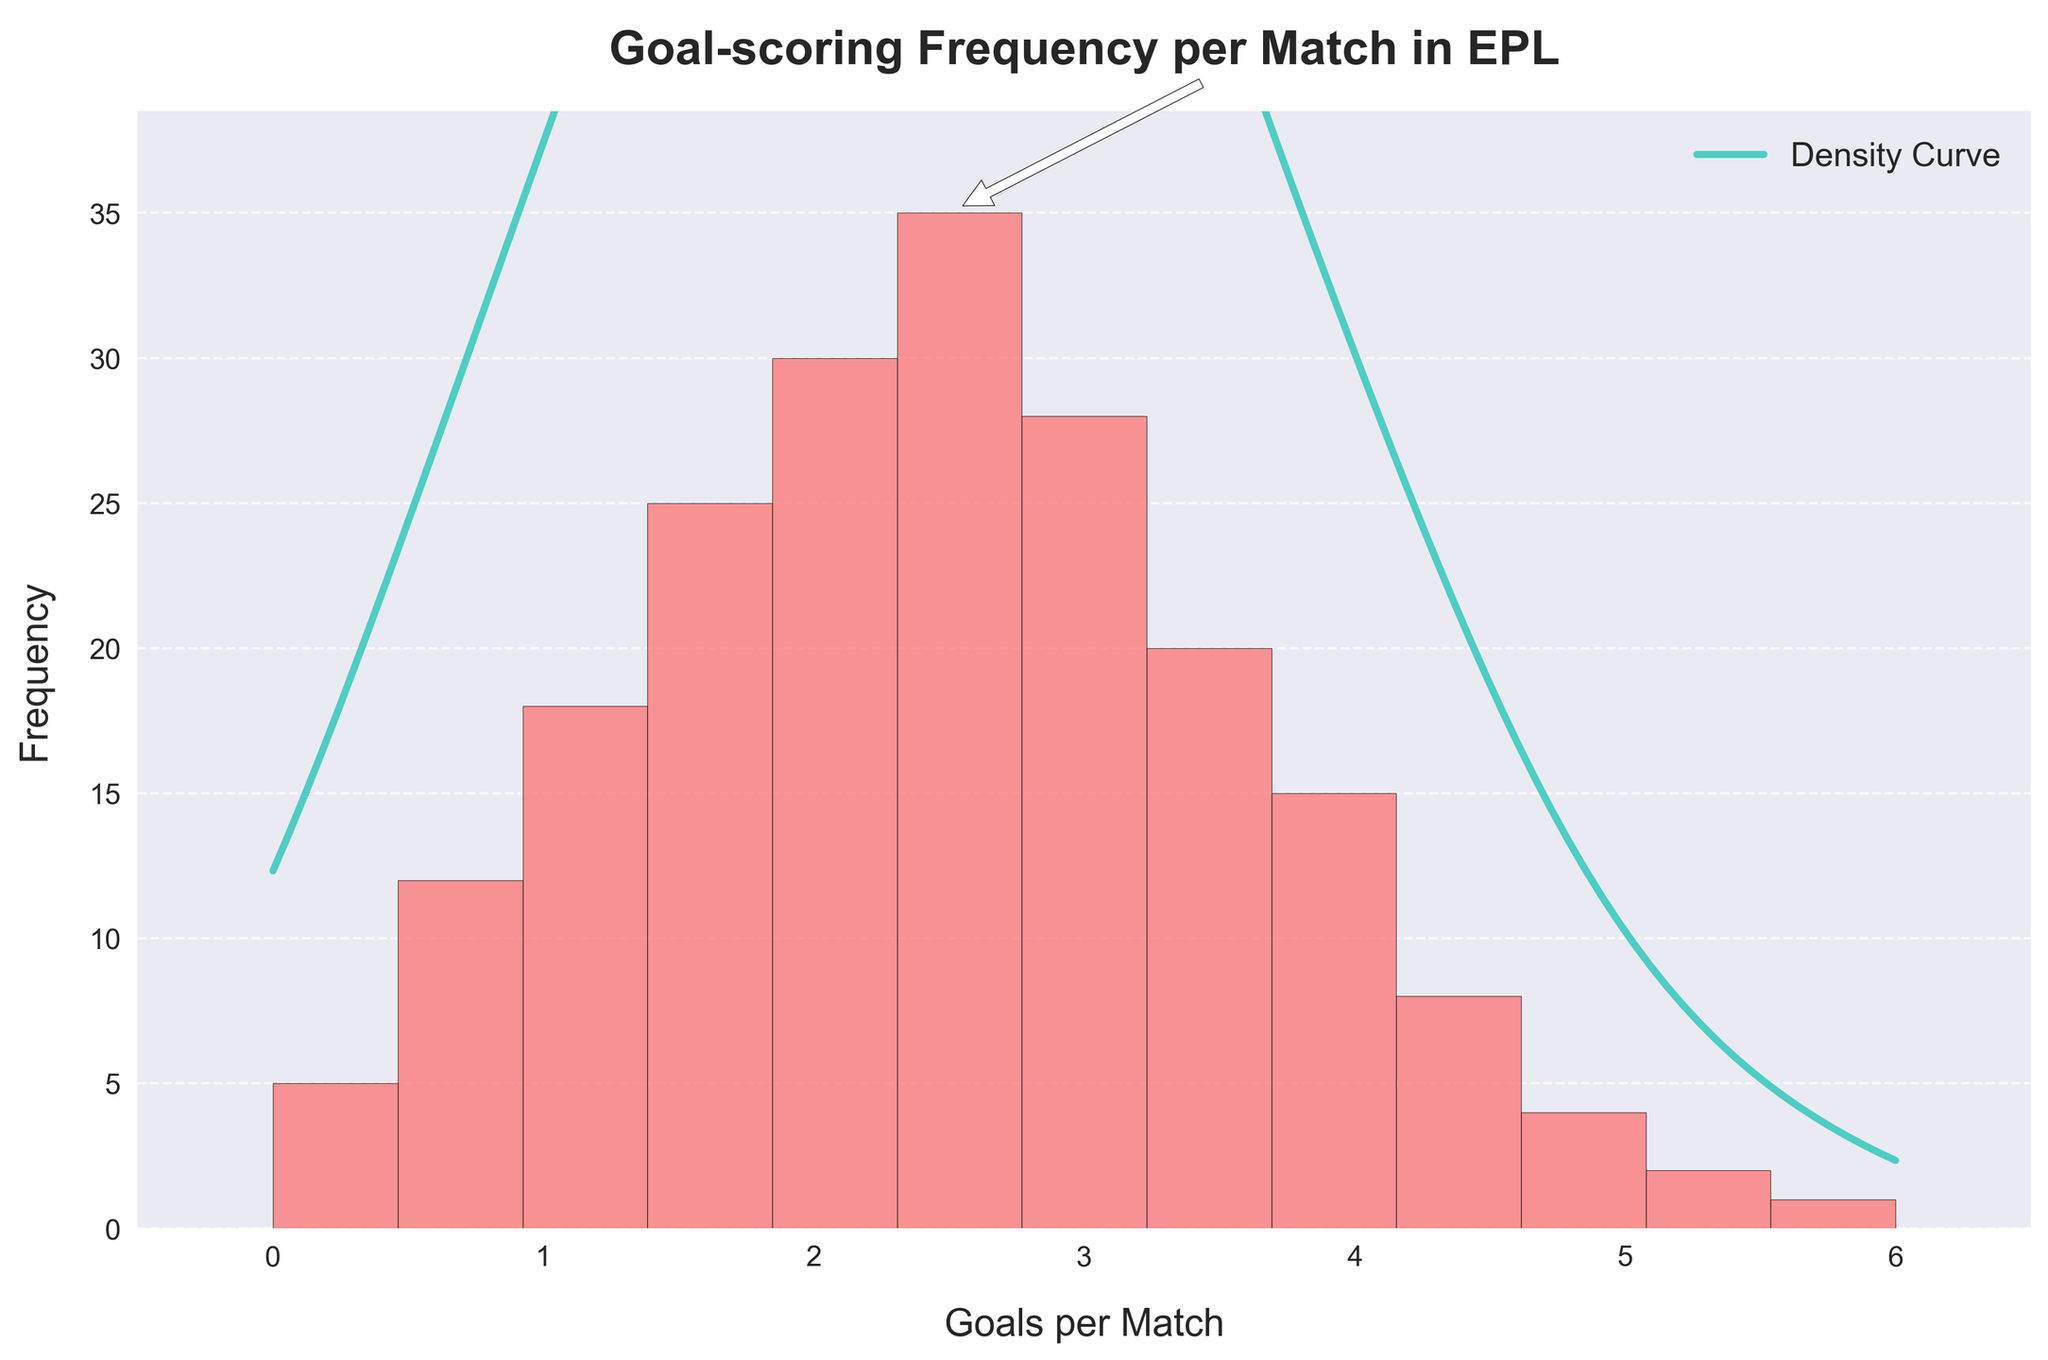What is the title of the histogram? The title is displayed prominently at the top of the figure, indicating the main focus of the plot.
Answer: Goal-scoring Frequency per Match in EPL Which color is used for the histogram bars? The color of the histogram bars can be observed in the figure, which helps identify the visual encoding.
Answer: Red (#FF6B6B) How many matches had exactly 3 goals? Look at the bar corresponding to '3' on the x-axis and read the height (frequency) of the bar.
Answer: 28 matches What is the range of goals per match shown on the x-axis? The x-axis of the histogram shows the range of goals per match from the minimum to the maximum value represented.
Answer: 0 to 6 Which goal frequency has the highest number of matches? Identify the tallest bar in the histogram to find the goal frequency with the peak number of matches.
Answer: 2.5 goals What is the approximate frequency for 1.5 goals per match? Locate the bar corresponding to 1.5 on the x-axis and check its height (frequency).
Answer: 25 matches Compare the number of matches with 2 goals per match to those with 3 goals per match. Identify the heights of the bars with 2 goals and 3 goals, then directly compare these frequencies.
Answer: 2 goals (30 matches) > 3 goals (28 matches) Which range of goals per match shows the steepest decline in frequency? Observe the slope of the density curve (KDE) and the changes in bar heights to determine where the frequency drops fastest.
Answer: 3.5 to 4.5 goals What is the total frequency of matches with 2 or more goals? Sum the frequencies of all bars corresponding to 2 goals and higher on the x-axis: 2 (30) + 2.5 (35) + 3 (28) + 3.5 (20) + 4 (15) + 4.5 (8) + 5 (4) + 5.5 (2) + 6 (1).
Answer: 143 matches Analyzing the peak annotation, how many matches had the peak goal frequency? The plot contains an annotation indicating the peak frequency, referring to the maximum bar in the histogram.
Answer: 35 matches 